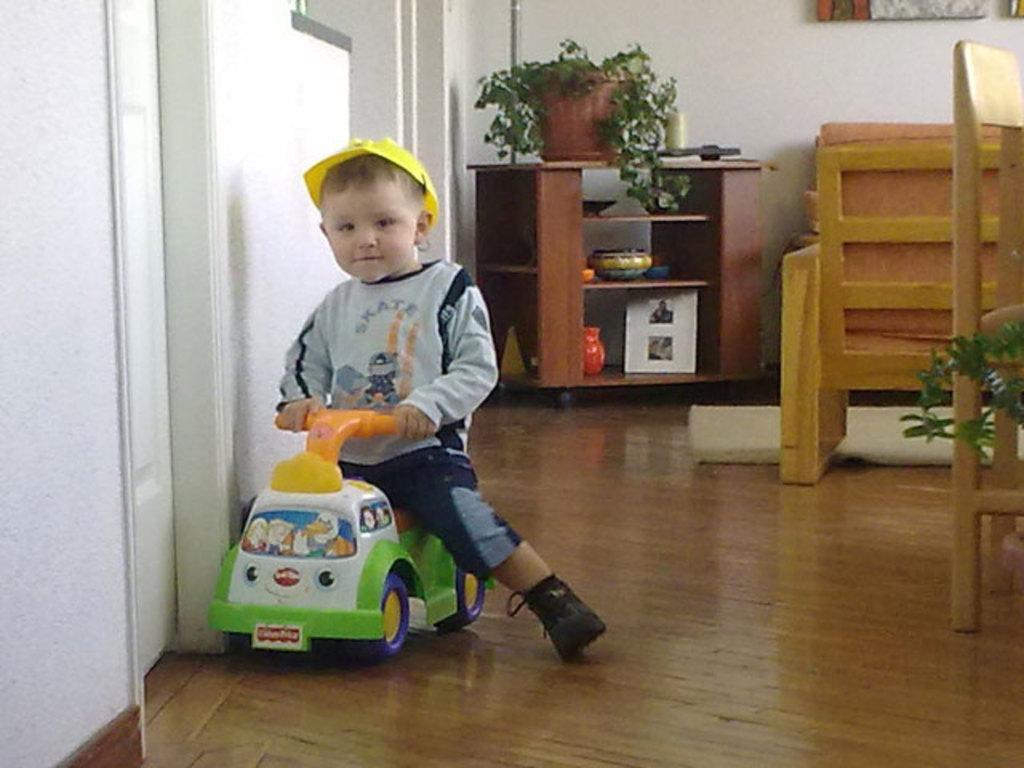How would you summarize this image in a sentence or two? In this image there is a boy sitting on the toy. Behind him there is a table and on top of it there is a plant and few other objects. At the left side of the image there is a door. At the right side of the image there are chairs. At the back side there is a wall. 